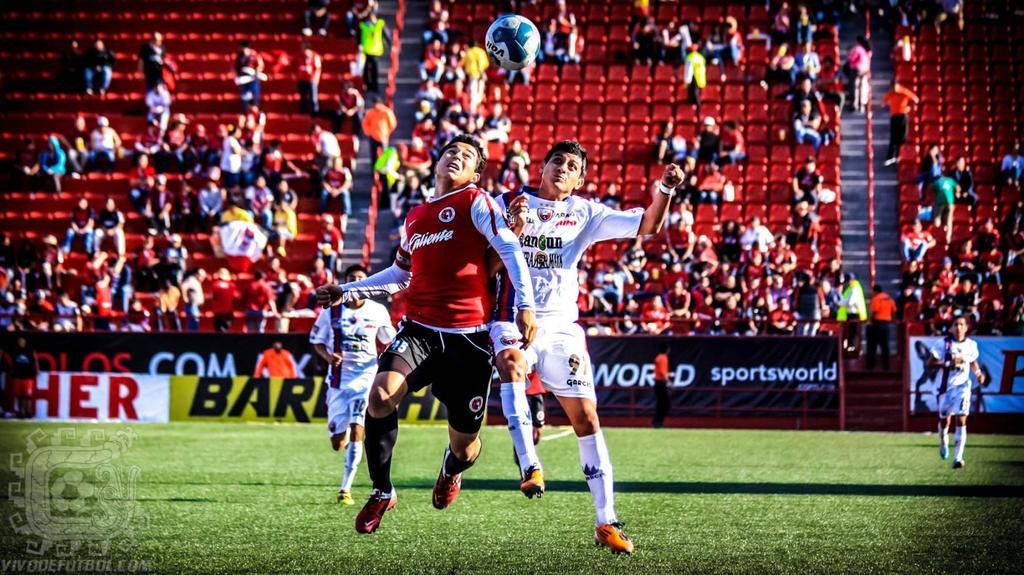<image>
Share a concise interpretation of the image provided. A group of players playing a soccer game sponsored by Sportsworld. 